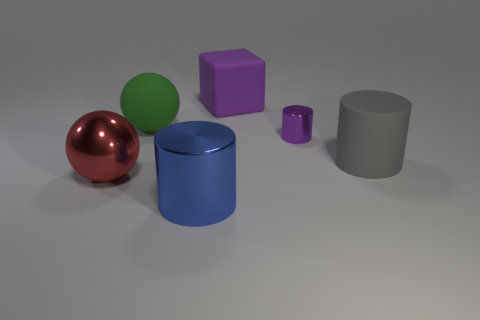Subtract all gray cylinders. How many cylinders are left? 2 Add 2 purple matte spheres. How many objects exist? 8 Subtract 1 balls. How many balls are left? 1 Subtract all blue cylinders. How many cylinders are left? 2 Subtract all balls. How many objects are left? 4 Add 1 big yellow cylinders. How many big yellow cylinders exist? 1 Subtract 1 red balls. How many objects are left? 5 Subtract all gray cylinders. Subtract all purple balls. How many cylinders are left? 2 Subtract all small green shiny blocks. Subtract all matte cubes. How many objects are left? 5 Add 6 rubber cylinders. How many rubber cylinders are left? 7 